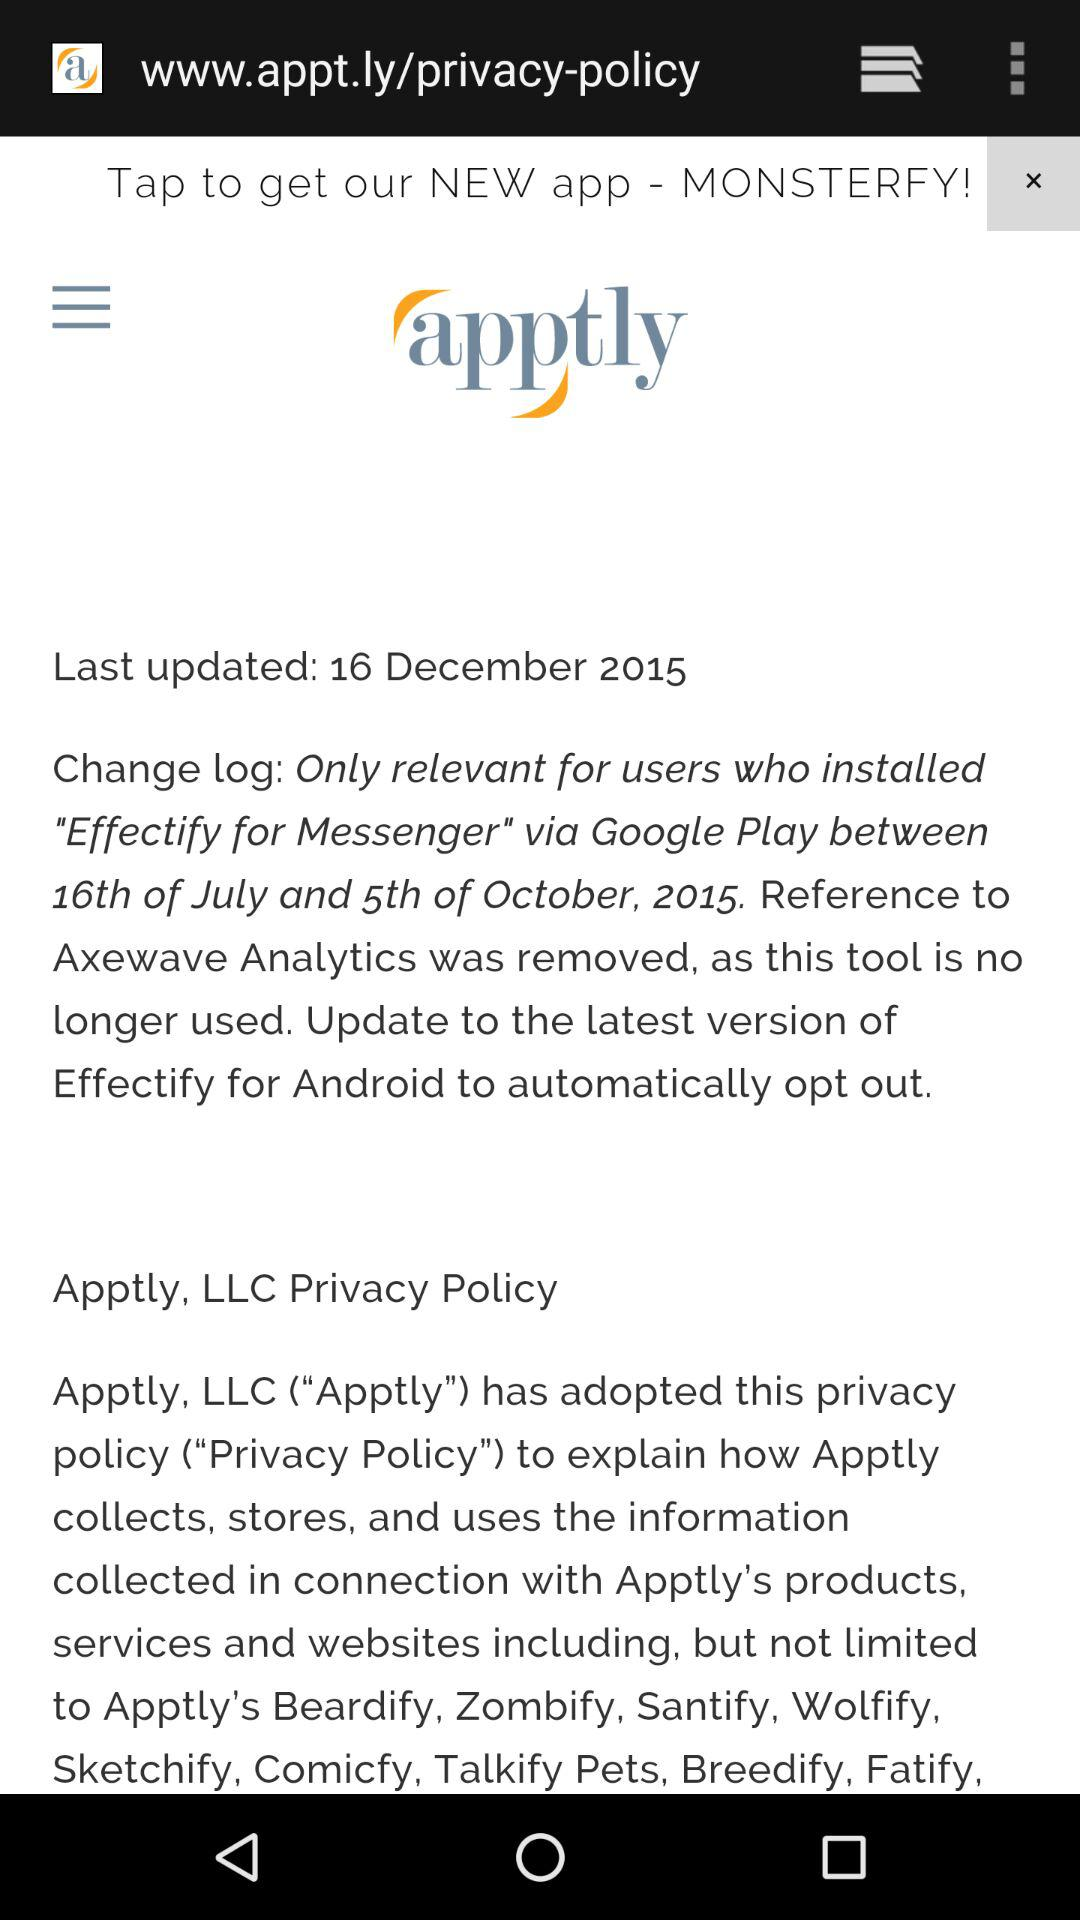How many apptly logos are there?
Answer the question using a single word or phrase. 1 